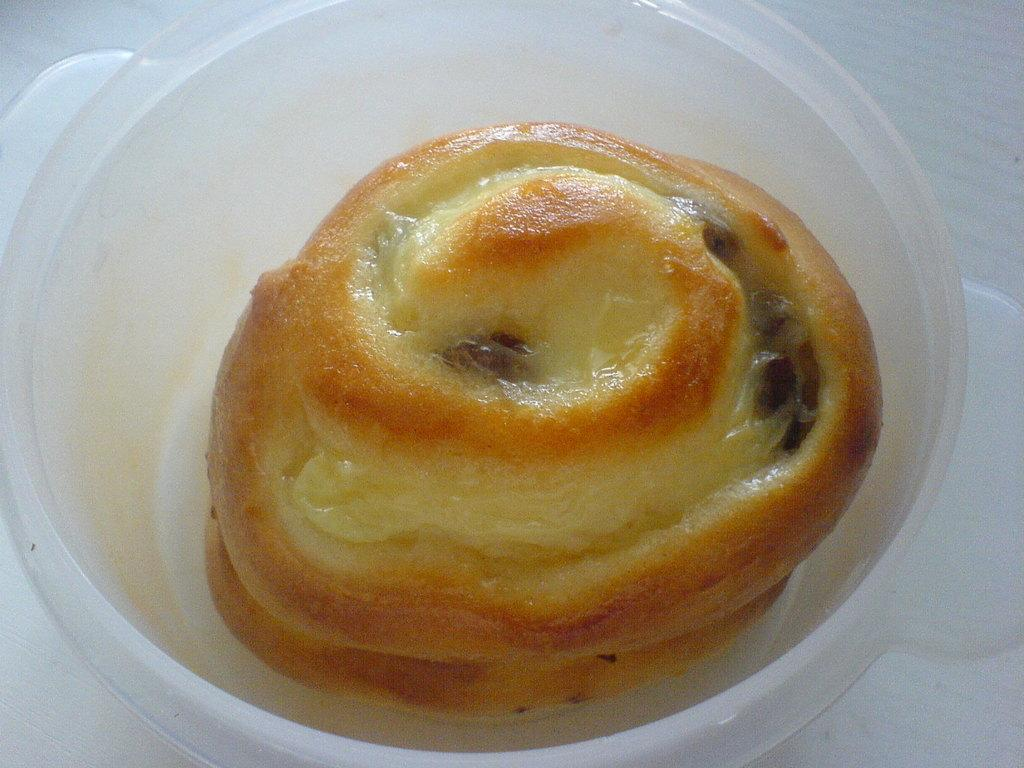What is the main subject of the image? The main subject of the image is food. How is the food contained in the image? The food is in a plastic bowl. What colors can be observed in the food? The food has brown and cream colors. Are there any deer visible in the garden in the image? There is no garden or deer present in the image; it features food in a plastic bowl. 